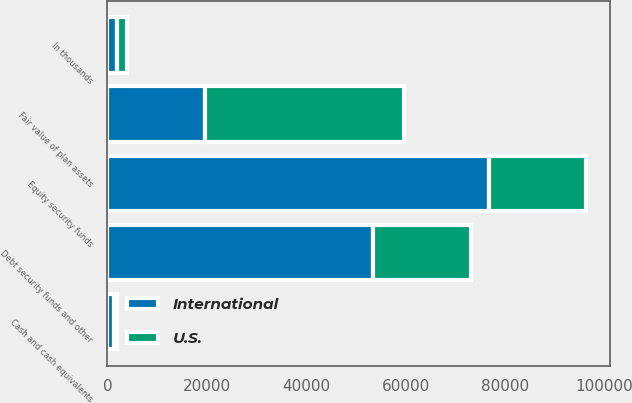Convert chart. <chart><loc_0><loc_0><loc_500><loc_500><stacked_bar_chart><ecel><fcel>In thousands<fcel>Equity security funds<fcel>Debt security funds and other<fcel>Cash and cash equivalents<fcel>Fair value of plan assets<nl><fcel>U.S.<fcel>2011<fcel>19669<fcel>19650<fcel>632<fcel>39951<nl><fcel>International<fcel>2011<fcel>76679<fcel>53396<fcel>1252<fcel>19650<nl></chart> 